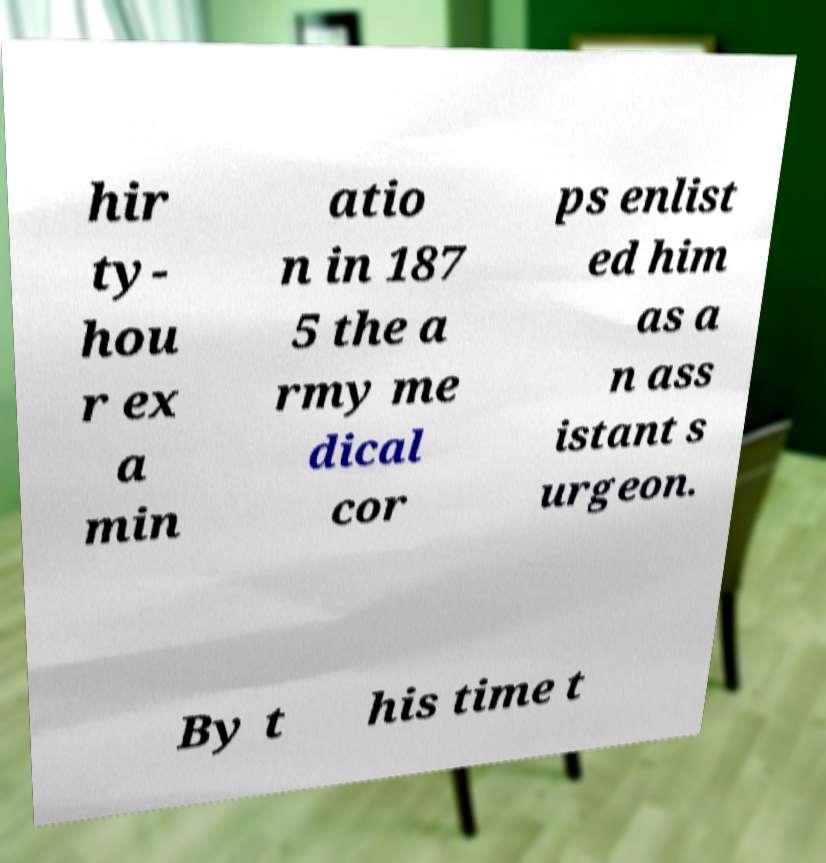Please read and relay the text visible in this image. What does it say? hir ty- hou r ex a min atio n in 187 5 the a rmy me dical cor ps enlist ed him as a n ass istant s urgeon. By t his time t 